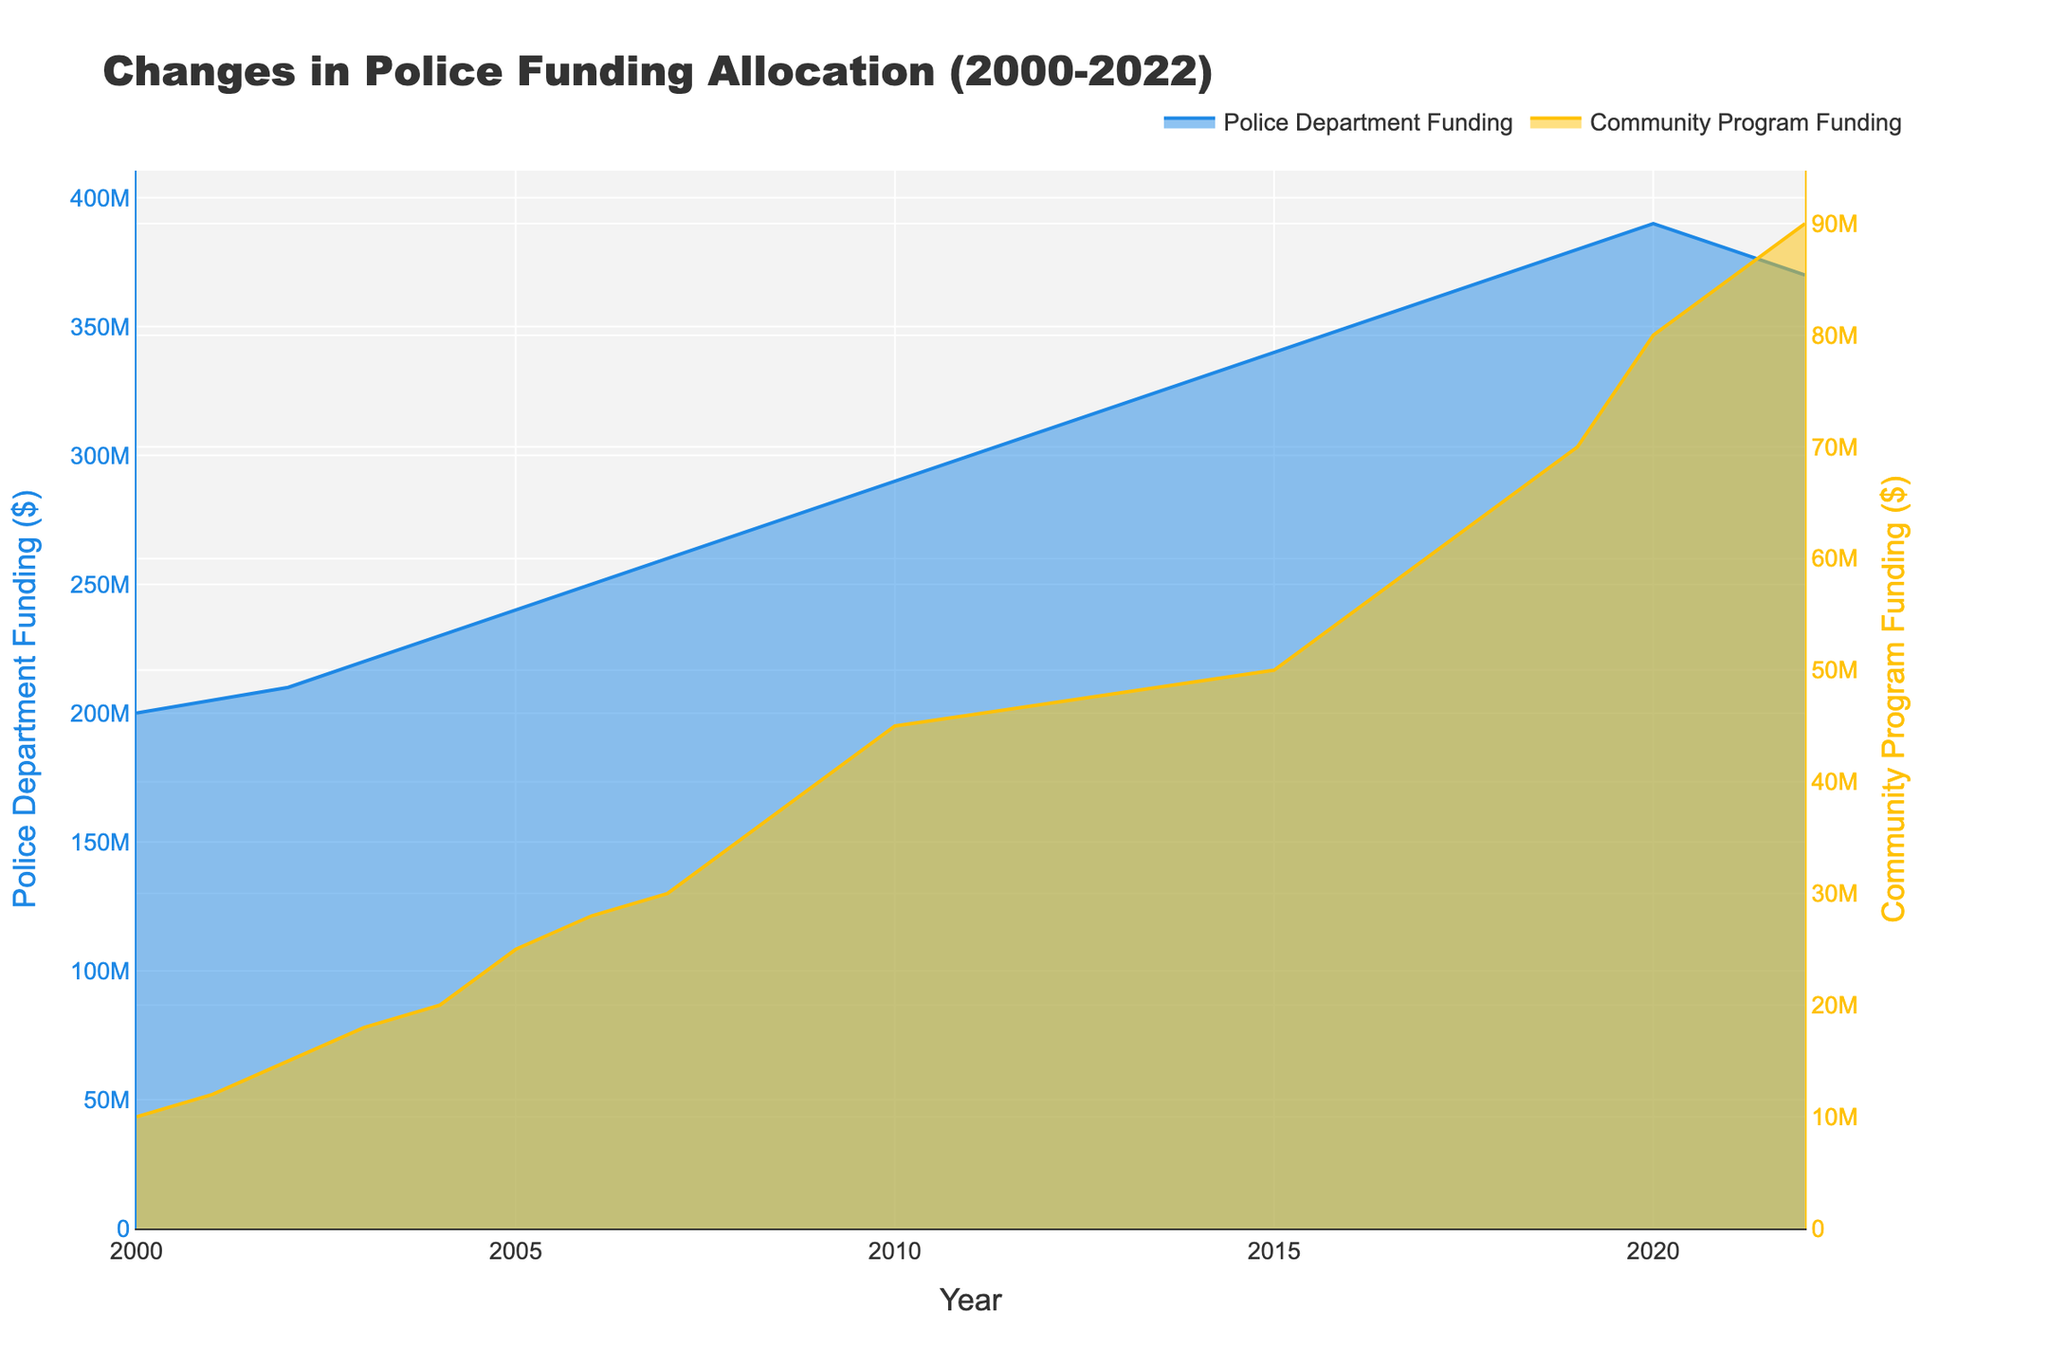What is the funding for police departments in 2022? Look at the value of the Police Department Funding line for the year 2022.
Answer: $370,000,000 How has the funding for community programs changed from 2000 to 2022? Find the value of Community Program Funding for the year 2000 and compare it to the value in 2022.
Answer: Increased by $80,000,000 Which year saw the highest funding for community programs? Identify the peak point in the Community Program Funding line.
Answer: 2022 In which year did police budget decline, and by how much did it decrease? Look for the year where there is a dip in the Police Department Funding line and calculate the difference. The decline occurred in 2021 where the funding decreased from $390,000,000 in 2020 to $380,000,000, and further declined to $370,000,000 in 2022.
Answer: 2021, decrease by $20,000,000 Compare the police and community program funding in 2010. Which was larger and by how much? Find the values for Police Department Funding and Community Program Funding for the year 2010, then subtract Community Program Funding from Police Department Funding.
Answer: Police funding is larger by $245,000,000 What is the trend of community program funding from 2015 to 2022? Examine the Community Program Funding line from 2015 to 2022 and describe the pattern.
Answer: Increasing trend By how much did police funding increase from 2000 to 2010? Subtract the 2000 police funding value from the 2010 police funding value.
Answer: Increased by $90,000,000 What is the overall trend in police department funding from 2000 to 2022? Evaluate the overall direction of the Police Department Funding line from 2000 to 2022 to determine if it is increasing, decreasing, or fluctuating.
Answer: Fluctuating after 2020, mostly increasing before that Calculate the average funding for community programs between 2000 and 2022. Sum all Community Program Funding values from 2000 to 2022 and divide by the number of years (23).
Answer: $41,739,130.43 Why might there be two separate y-axes in this plot? Two y-axes are often used to display data with different scales so each dataset can be easily read. This is especially important when there is a large difference in the magnitudes of the two datasets, like Police Department Funding and Community Program Funding here.
Answer: To display different scales 